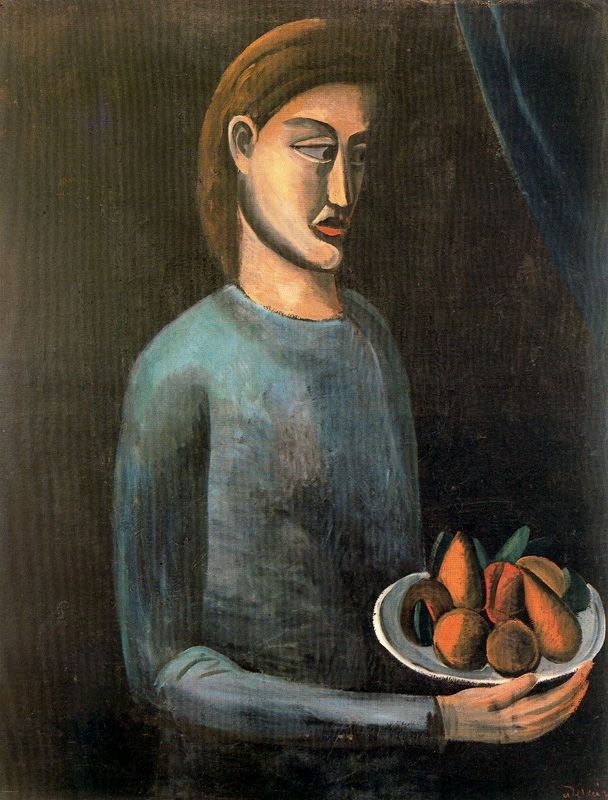Explain the visual content of the image in great detail. The image displays a striking portrayal of a woman in a simplified, modernist style, prominent in the early 20th century. She stands against a profoundly dark background, enhancing the muted yet poignant colors of her attire. The woman, characterized by an elongated face and simplified, yet expressive facial features, appears contemplative. Her eyes, depicted with mere strokes, and her elongated nose, add a sense of melancholy to her demeanor. She wears a light blue shirt, the soft color of which contrasts subtly with the deeper blue and shadowy elements of the background. In her hands, she delicately holds a white bowl containing vibrant fruit, including oranges and pears, which interrupt the overall somber tones with bursts of color. This fruit could symbolize fertility or the fleeting nature of life, typical themes in modernist art, which often sought to explore deeper psychological and existential themes through simplified forms and colors. 